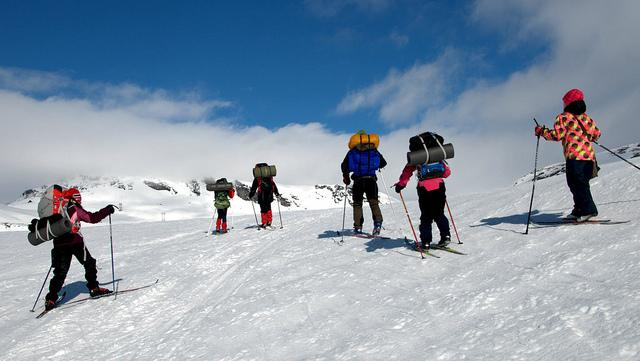Where are they going? uphill 